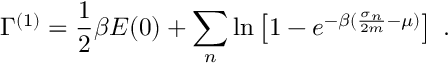<formula> <loc_0><loc_0><loc_500><loc_500>\Gamma ^ { ( 1 ) } = \frac { 1 } { 2 } \beta E ( 0 ) + \sum _ { n } \ln \left [ 1 - e ^ { - \beta ( \frac { \sigma _ { n } } { 2 m } - \mu ) } \right ] \, .</formula> 